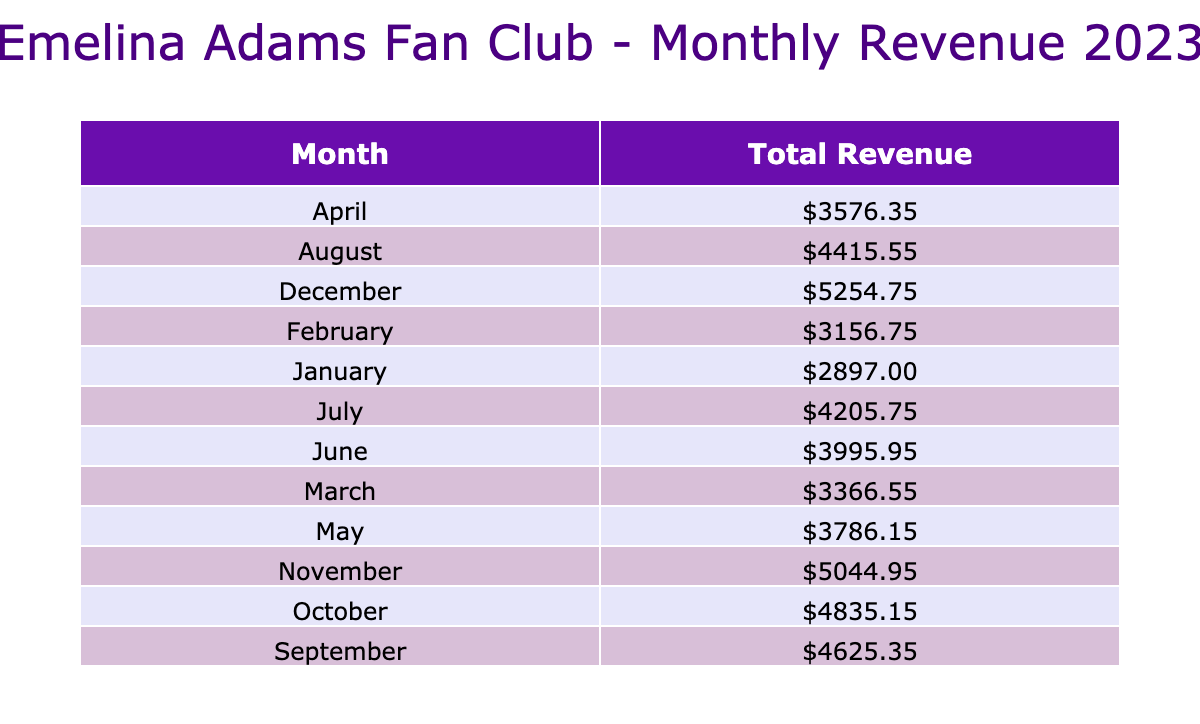What is the total revenue for January 2023? The table shows the total revenue is directly listed under January. For January, the total revenue calculated from all membership types is 898.50 + 999.00 + 999.50 = 2897.00. Thus, the total revenue for January is 2897.00.
Answer: 2897.00 Which month had the highest total revenue? By reviewing the total revenues for each month in the table, the maximum value is found in December, where the total revenue is 1557.40 + 1598.40 + 2098.95 = 5254.75. Therefore, December had the highest total revenue.
Answer: December What was the average revenue generated from Gold memberships in 2023? To find the average revenue from Gold memberships, first sum the total revenues across all months: 999.50 + 1099.45 + 1199.40 + 1299.35 + 1399.30 + 1499.25 + 1599.20 + 1699.15 + 1799.10 + 1899.05 + 1999.00 + 2098.95 = 16749.25. Then, divide by the total number of months (12). So, 16749.25 / 12 = 1395.77.
Answer: 1395.77 Did the Basic membership type generate more revenue than Silver membership for the entire year? The total revenue for Basic is 898.50 + 958.40 + 1018.30 + 1078.20 + 1138.10 + 1198.00 + 1257.90 + 1317.80 + 1377.70 + 1437.60 + 1497.50 + 1557.40 = 15239.10. The total revenue for Silver is 999.00 + 1098.90 + 1148.85 + 1198.80 + 1248.75 + 1298.70 + 1348.65 + 1398.60 + 1448.55 + 1498.50 + 1548.45 + 1598.40 = 15677.75. Since 15239.10 < 15677.75, the statement is false.
Answer: No What is the total revenue for all membership types in June 2023? To find the total revenue for June, I add the revenues from all membership types for that month: 1198.00 + 1298.70 + 1499.25 = 3995.95. Thus, the total revenue for June is 3995.95.
Answer: 3995.95 